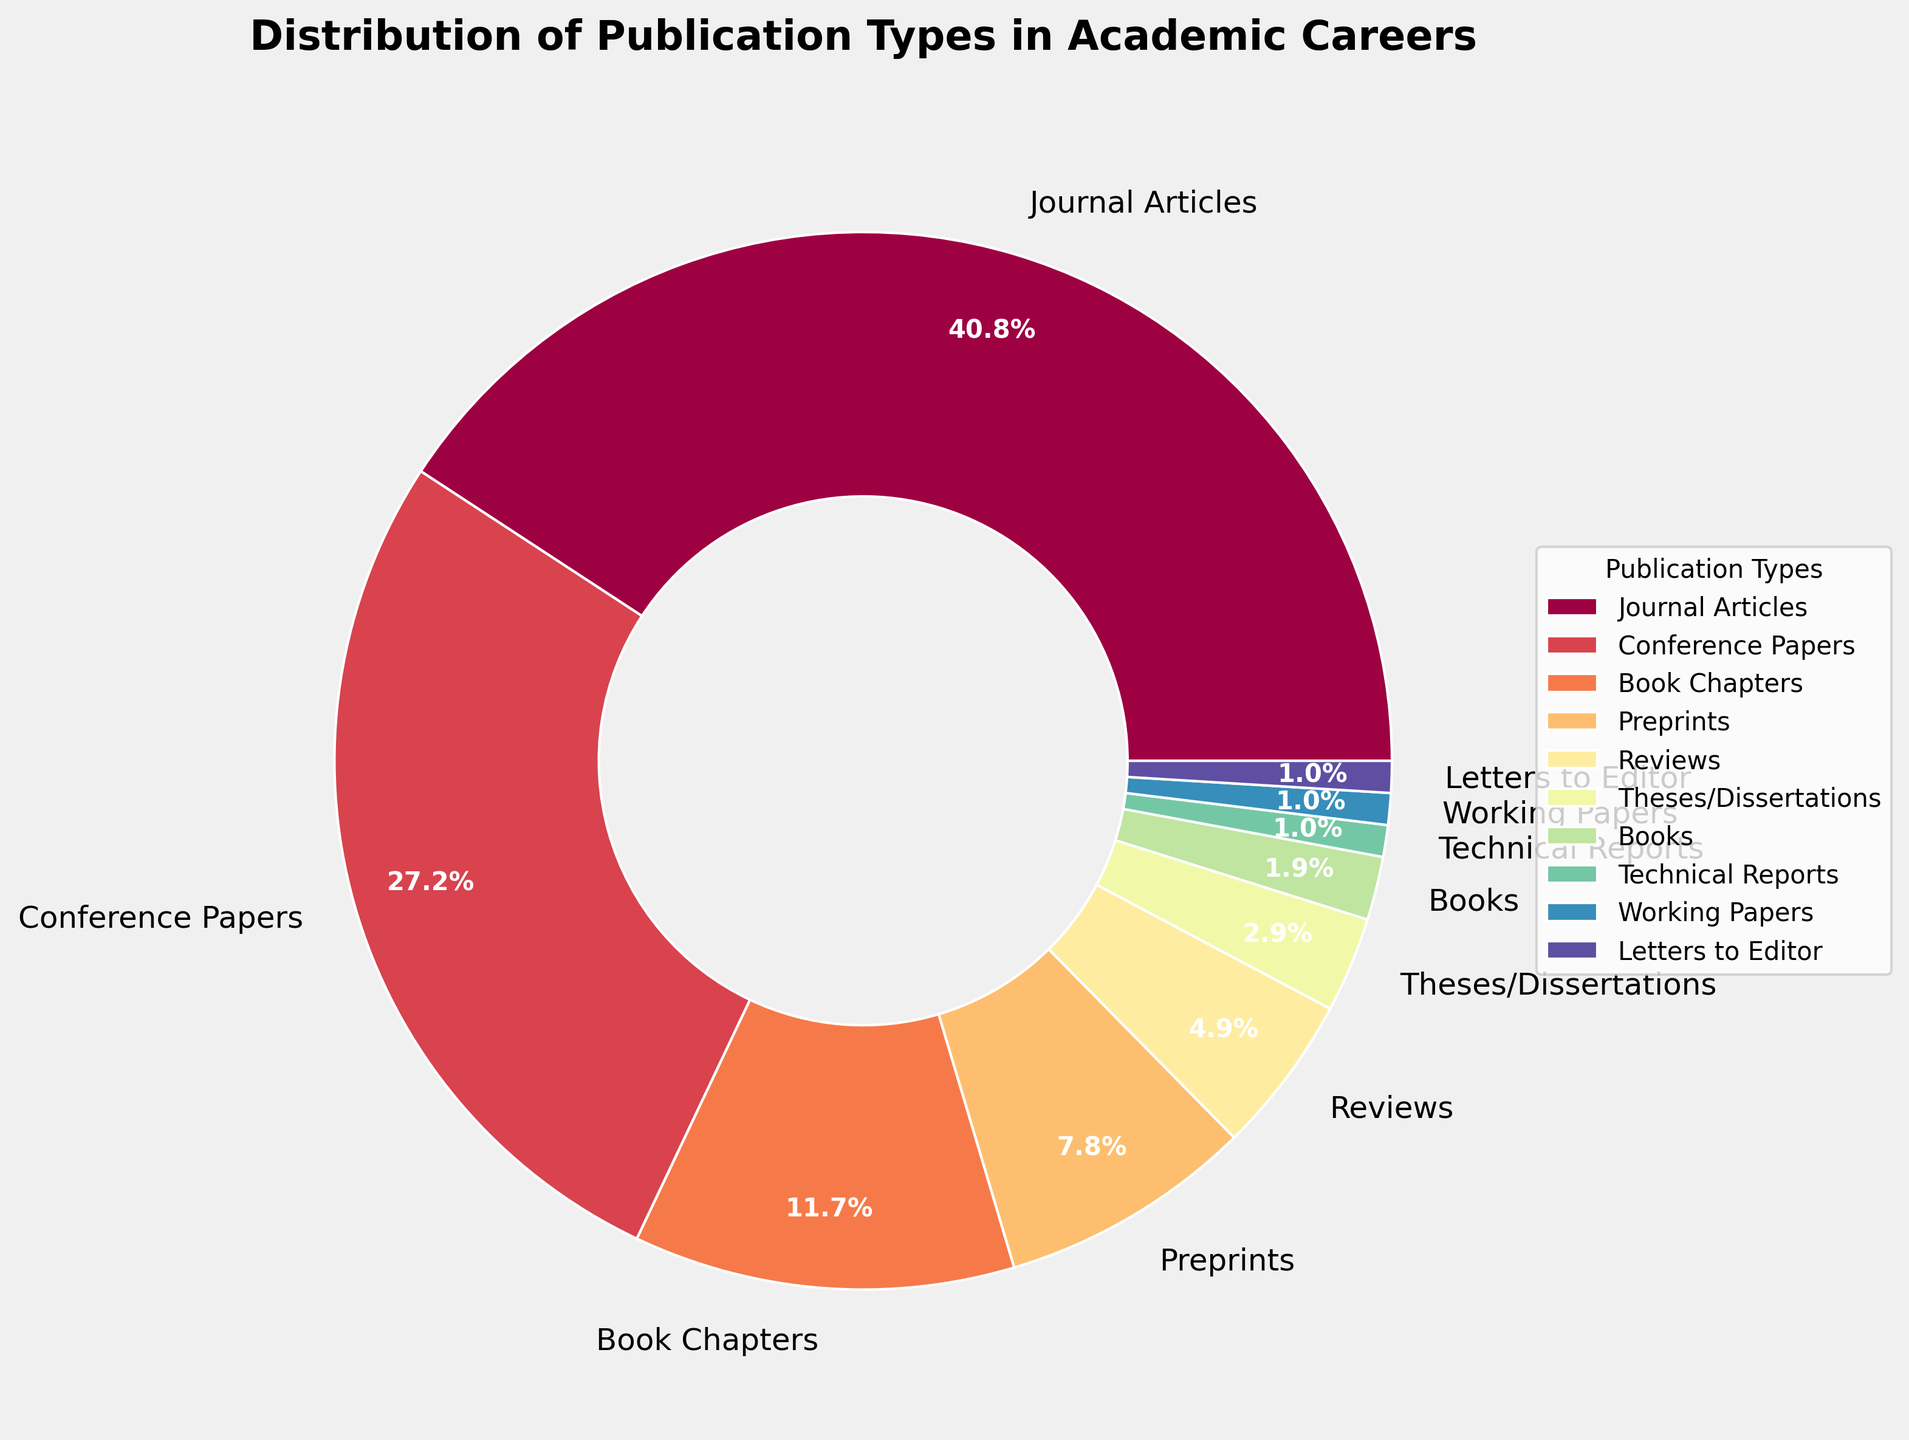What percentage of publication types are Journal Articles and Conference Papers together? To find the combined percentage, add the percentages of Journal Articles and Conference Papers: 42% + 28% = 70%
Answer: 70% Which publication type has the smallest percentage? The publication type with the smallest percentage is the one with the lowest value in the data. According to the figure, Technical Reports, Working Papers, and Letters to Editor each have 1%.
Answer: Technical Reports, Working Papers, and Letters to Editor Are there more Preprints or Book Chapters? Compare the percentages for Preprints and Book Chapters. Preprints are 8%, while Book Chapters are 12%. 8% is less than 12%.
Answer: Book Chapters What is the ratio of Reviews to Books? To find the ratio, divide the percentage of Reviews by the percentage of Books: 5% / 2% = 2.5. So, the ratio is 2.5:1.
Answer: 2.5:1 If you remove Journal Articles and Conference Papers, what percentage of the total do the remaining publication types represent? First, find the combined percentage of Journal Articles and Conference Papers: 42% + 28% = 70%. Then, subtract that from 100% to find the remaining percentage: 100% - 70% = 30%.
Answer: 30% Which publication types are represented by more than 10% each? Look for all publication types with percentages greater than 10%. According to the data, Journal Articles (42%) and Conference Papers (28%) are the only types above 10%.
Answer: Journal Articles, Conference Papers Do Preprints and Reviews together make up a larger or smaller percentage than Book Chapters? Add the percentages of Preprints and Reviews: 8% + 5% = 13%. Compare that with the percentage of Book Chapters, which is 12%. 13% is greater than 12%.
Answer: Larger How many more percentage points do Journal Articles have compared to the total of Theses/Dissertations, Books, Technical Reports, Working Papers, and Letters to Editor combined? Sum the percentages of Theses/Dissertations (3%), Books (2%), Technical Reports (1%), Working Papers (1%), and Letters to Editor (1%): 3% + 2% + 1% + 1% + 1% = 8%. Then, subtract this from the percentage of Journal Articles: 42% - 8% = 34%.
Answer: 34% 